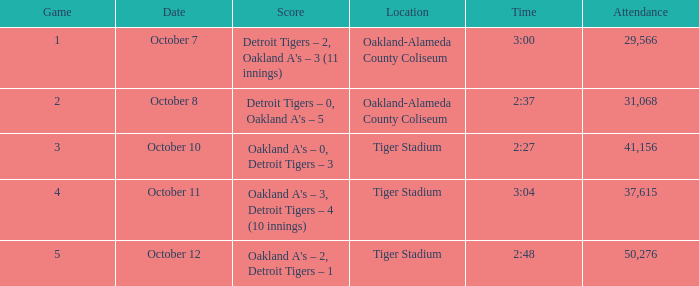How many people are attending the oakland-alameda county coliseum, and game is 2? 31068.0. 